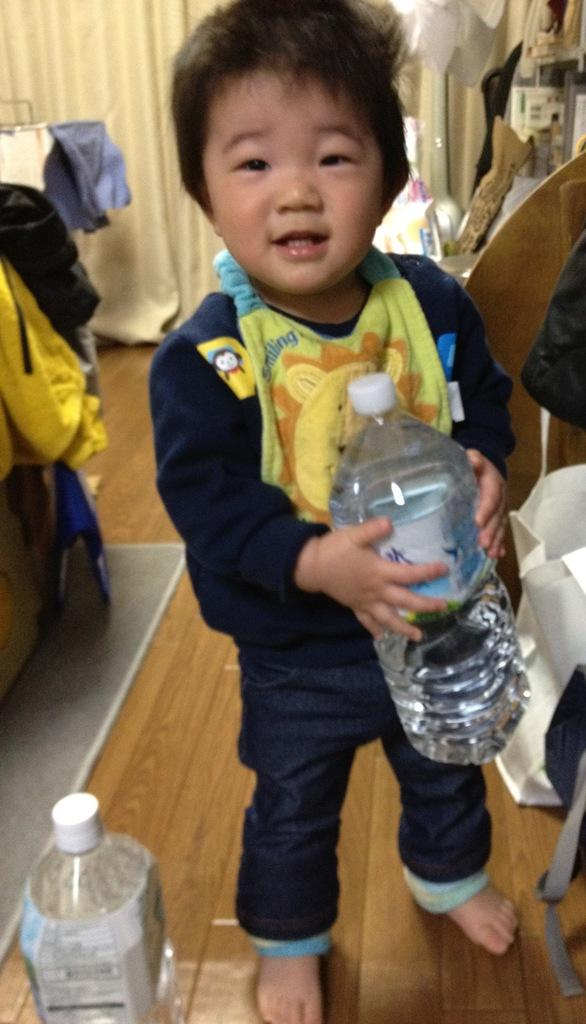Who is the main subject in the image? There is a small boy in the image. What is the boy wearing? The boy is wearing a blue shirt and shorts. What is the boy holding in the image? The boy is holding a water bottle. Are there any other water bottles visible in the image? Yes, there is another water bottle beside the boy. Are there any giants attacking the small boy in the image? No, there are no giants or any signs of attack in the image. 